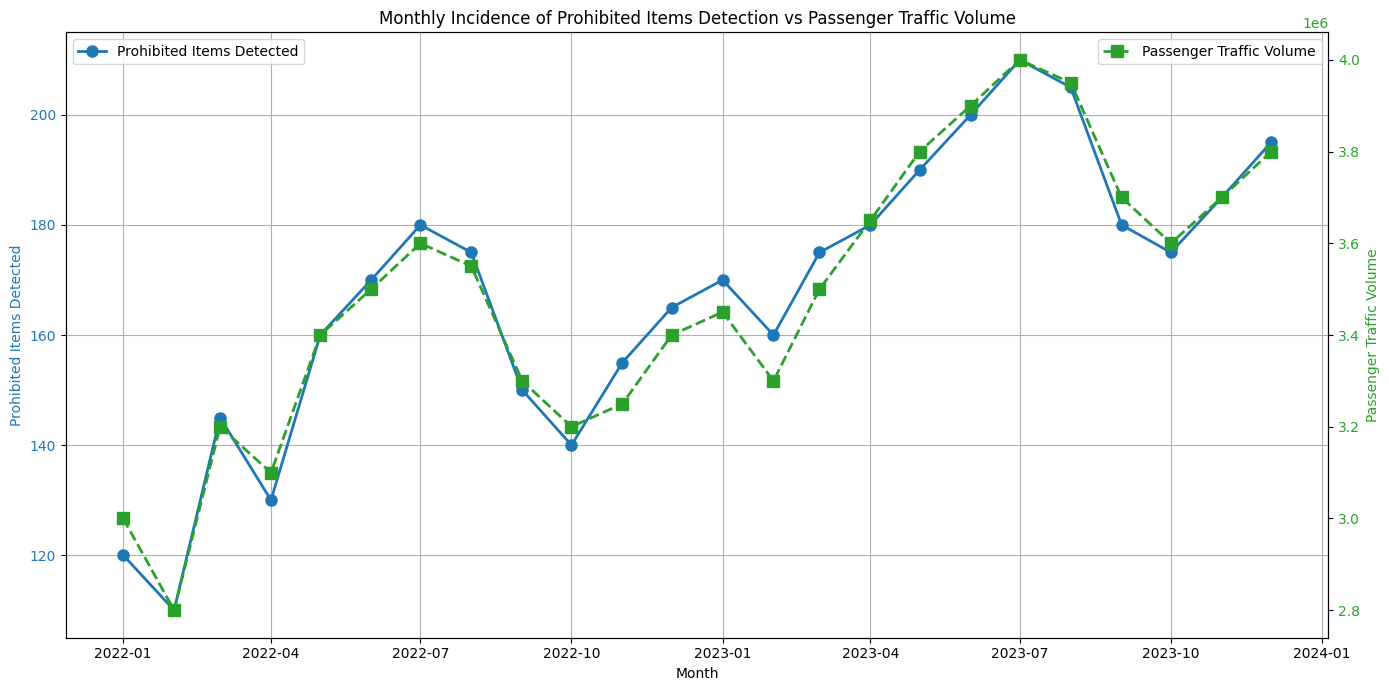Which month had the highest number of prohibited items detected? Look at the blue line and identify the highest point on the vertical axis labeled “Prohibited Items Detected.”
Answer: July 2023 Which month had the lowest passenger traffic volume? Observe the green line and find the lowest point on the vertical axis labeled “Passenger Traffic Volume.”
Answer: February 2022 Is there a month where the number of prohibited items detected dropped compared to the previous month? Scan the blue line for any descending segments from one month to the next.
Answer: February 2022 What is the total number of prohibited items detected from January 2022 to December 2023? Sum all the values of the blue marker data points for prohibited items detected.
Answer: 3660 During which months do both the number of prohibited items detected and passenger traffic volume peak? Identify the month where both the blue and green lines reach their respective highest points.
Answer: July 2023 What is the average passenger traffic volume for the year 2022? Sum all the passenger traffic volumes from January 2022 to December 2022, then divide by 12.
Answer: 3325000 Which month in 2023 saw a higher number of prohibited items detected compared to the average of 2022? Calculate the average number from January 2022 to December 2022 and compare each month in 2023.
Answer: All months in 2023 Between January 2022 and December 2023, how many months saw more prohibited items detected compared to passenger traffic volume in millions? Look for months where the blue line's value is greater than the green line divided by a million.
Answer: None Which month had the highest passenger traffic volume with a relatively small increase in prohibited items detected from the previous month? Look for the green line's peak with a small preceding month-to-month increase in the blue line.
Answer: August 2023 How many months showed both an increase in passenger traffic volume and prohibited items detected compared to the previous month? Count instances of simultaneous increases in both lines.
Answer: 7 